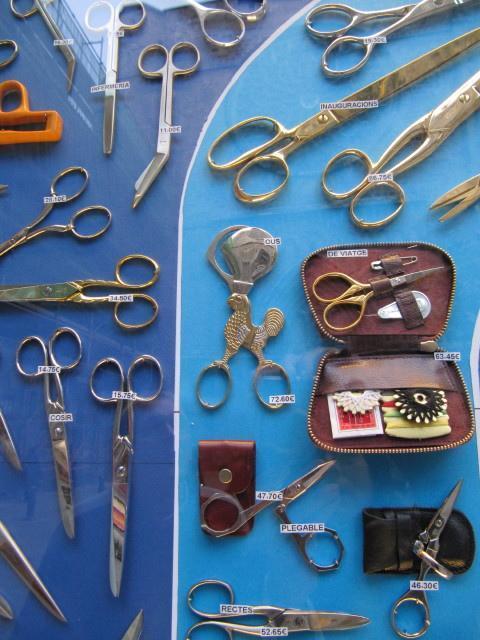How many scissors can you see?
Give a very brief answer. 14. How many little elephants are in the image?
Give a very brief answer. 0. 